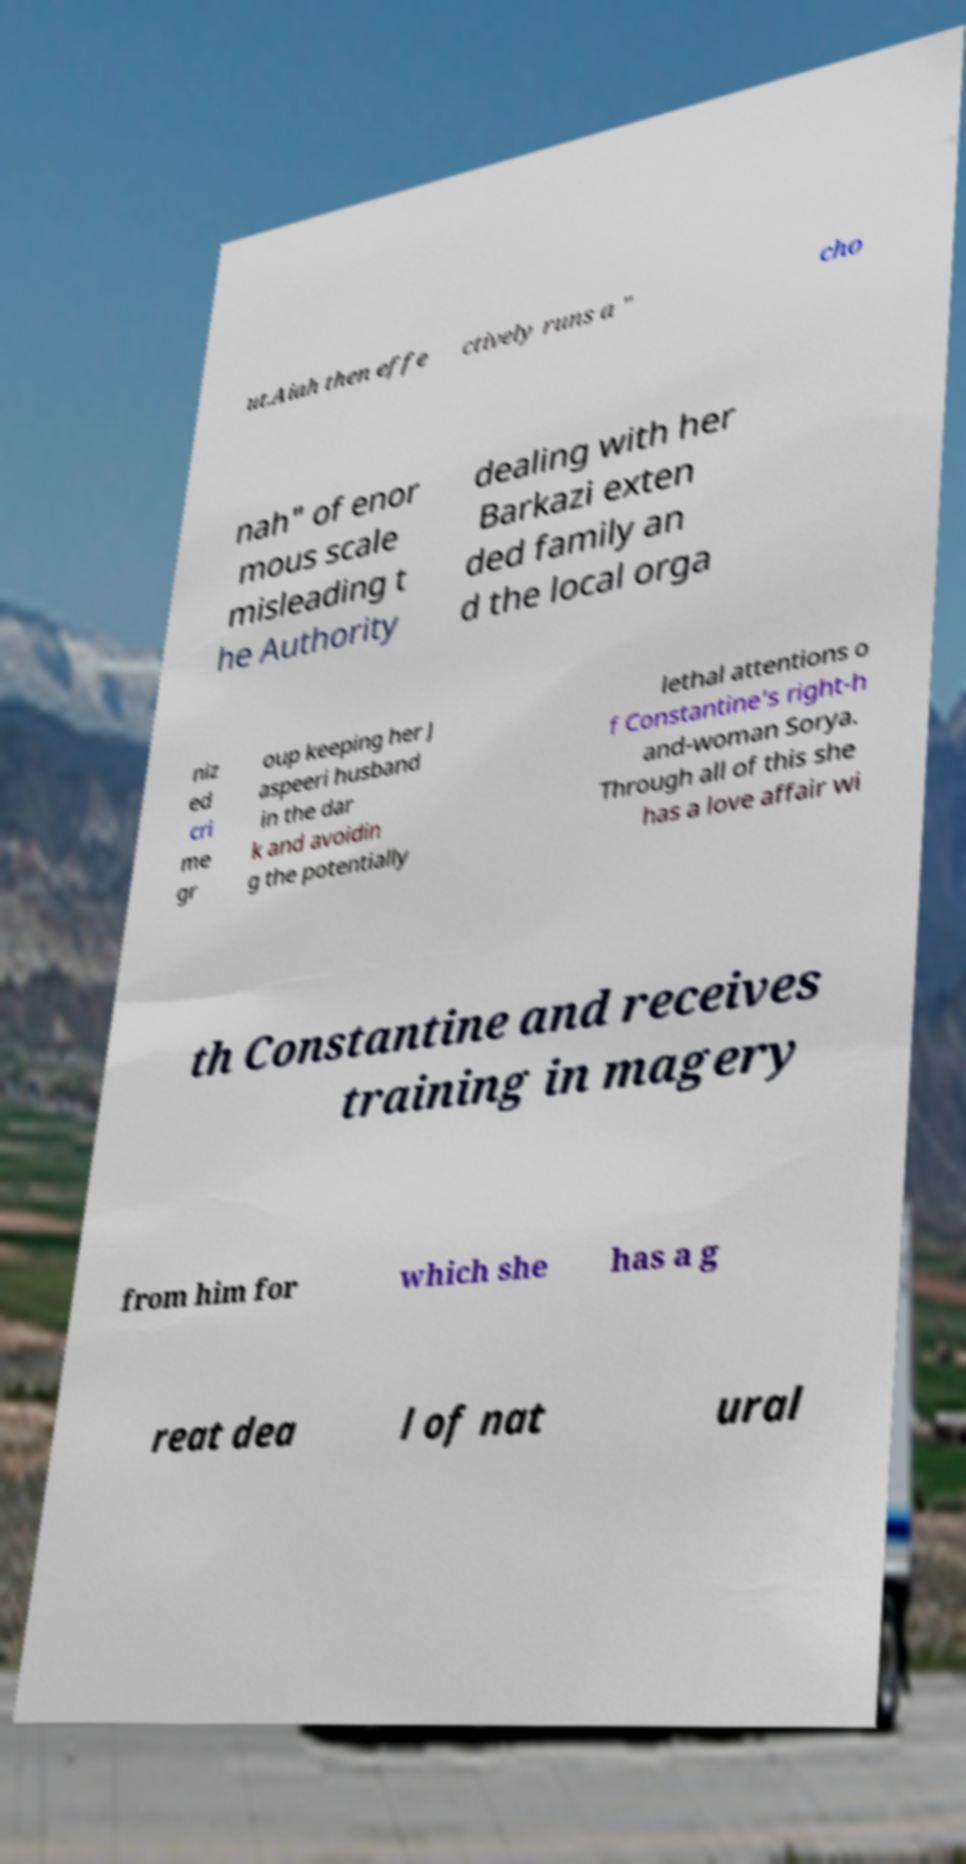Can you accurately transcribe the text from the provided image for me? ut.Aiah then effe ctively runs a " cho nah" of enor mous scale misleading t he Authority dealing with her Barkazi exten ded family an d the local orga niz ed cri me gr oup keeping her J aspeeri husband in the dar k and avoidin g the potentially lethal attentions o f Constantine's right-h and-woman Sorya. Through all of this she has a love affair wi th Constantine and receives training in magery from him for which she has a g reat dea l of nat ural 